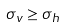Convert formula to latex. <formula><loc_0><loc_0><loc_500><loc_500>\sigma _ { v } \geq \sigma _ { h }</formula> 